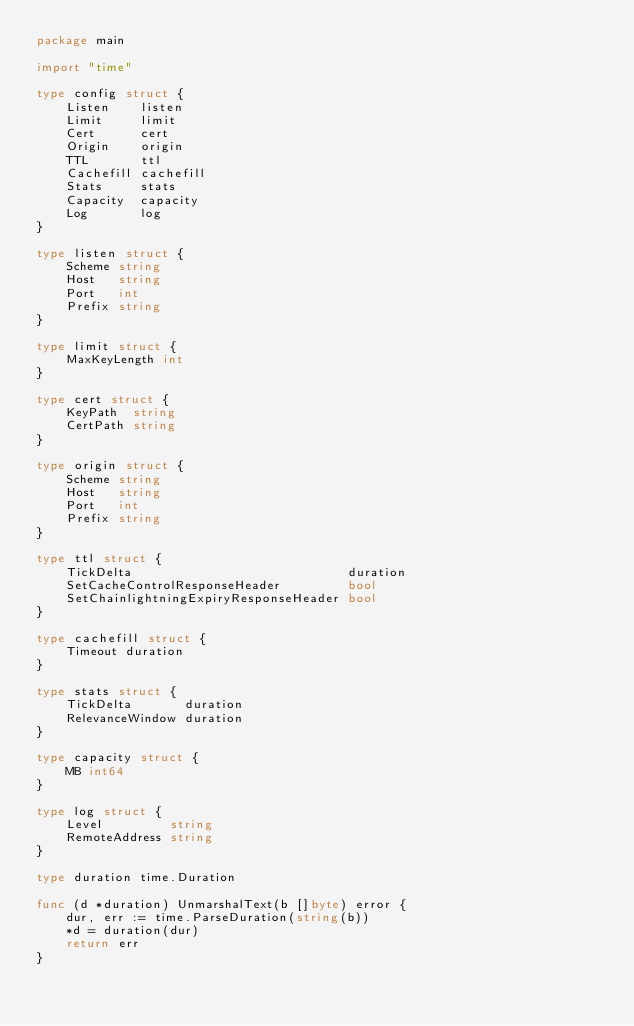Convert code to text. <code><loc_0><loc_0><loc_500><loc_500><_Go_>package main

import "time"

type config struct {
	Listen    listen
	Limit     limit
	Cert      cert
	Origin    origin
	TTL       ttl
	Cachefill cachefill
	Stats     stats
	Capacity  capacity
	Log       log
}

type listen struct {
	Scheme string
	Host   string
	Port   int
	Prefix string
}

type limit struct {
	MaxKeyLength int
}

type cert struct {
	KeyPath  string
	CertPath string
}

type origin struct {
	Scheme string
	Host   string
	Port   int
	Prefix string
}

type ttl struct {
	TickDelta                             duration
	SetCacheControlResponseHeader         bool
	SetChainlightningExpiryResponseHeader bool
}

type cachefill struct {
	Timeout duration
}

type stats struct {
	TickDelta       duration
	RelevanceWindow duration
}

type capacity struct {
	MB int64
}

type log struct {
	Level         string
	RemoteAddress string
}

type duration time.Duration

func (d *duration) UnmarshalText(b []byte) error {
	dur, err := time.ParseDuration(string(b))
	*d = duration(dur)
	return err
}
</code> 